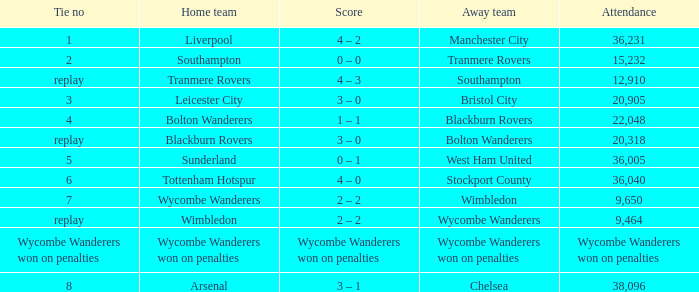What was the name of the away team that had a tie of 2? Tranmere Rovers. 